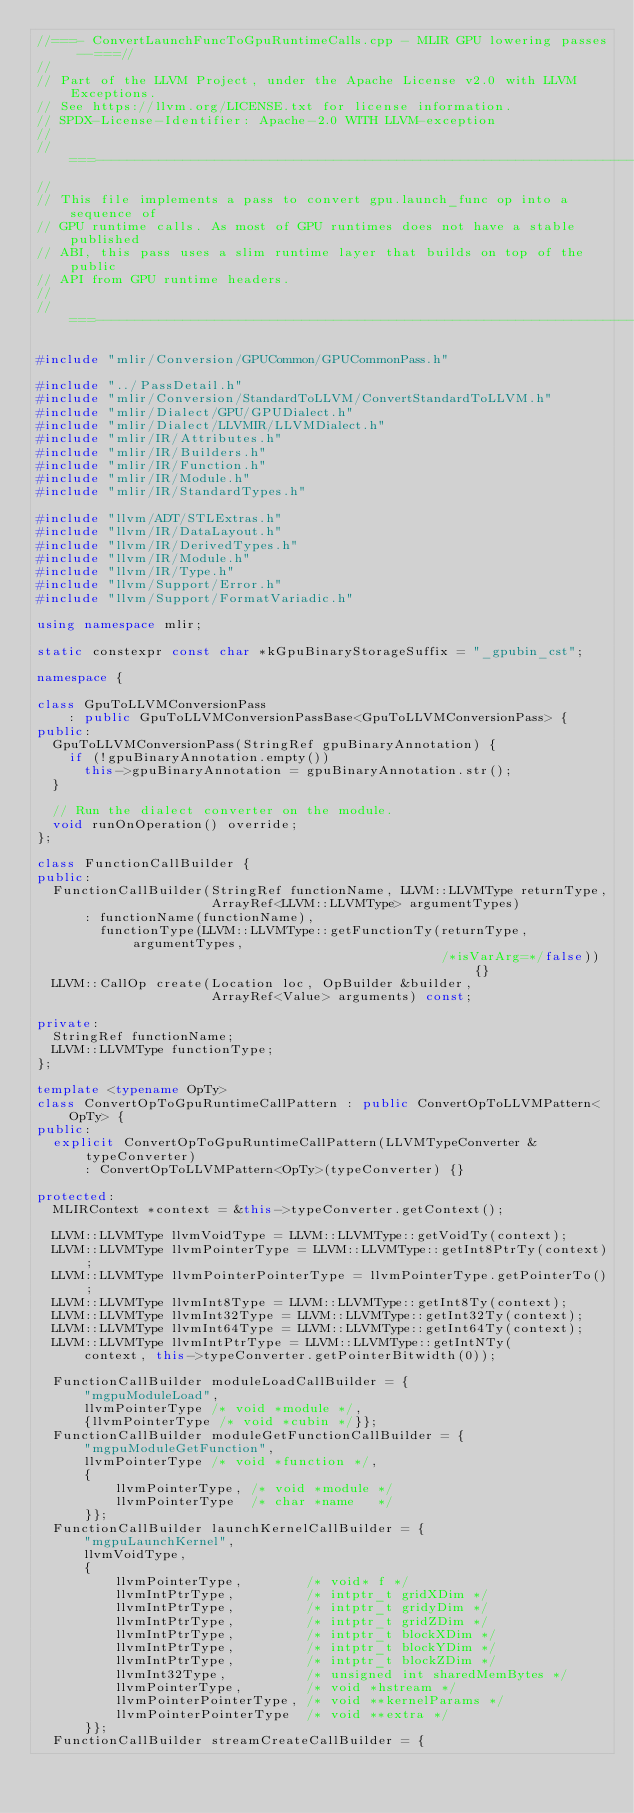<code> <loc_0><loc_0><loc_500><loc_500><_C++_>//===- ConvertLaunchFuncToGpuRuntimeCalls.cpp - MLIR GPU lowering passes --===//
//
// Part of the LLVM Project, under the Apache License v2.0 with LLVM Exceptions.
// See https://llvm.org/LICENSE.txt for license information.
// SPDX-License-Identifier: Apache-2.0 WITH LLVM-exception
//
//===----------------------------------------------------------------------===//
//
// This file implements a pass to convert gpu.launch_func op into a sequence of
// GPU runtime calls. As most of GPU runtimes does not have a stable published
// ABI, this pass uses a slim runtime layer that builds on top of the public
// API from GPU runtime headers.
//
//===----------------------------------------------------------------------===//

#include "mlir/Conversion/GPUCommon/GPUCommonPass.h"

#include "../PassDetail.h"
#include "mlir/Conversion/StandardToLLVM/ConvertStandardToLLVM.h"
#include "mlir/Dialect/GPU/GPUDialect.h"
#include "mlir/Dialect/LLVMIR/LLVMDialect.h"
#include "mlir/IR/Attributes.h"
#include "mlir/IR/Builders.h"
#include "mlir/IR/Function.h"
#include "mlir/IR/Module.h"
#include "mlir/IR/StandardTypes.h"

#include "llvm/ADT/STLExtras.h"
#include "llvm/IR/DataLayout.h"
#include "llvm/IR/DerivedTypes.h"
#include "llvm/IR/Module.h"
#include "llvm/IR/Type.h"
#include "llvm/Support/Error.h"
#include "llvm/Support/FormatVariadic.h"

using namespace mlir;

static constexpr const char *kGpuBinaryStorageSuffix = "_gpubin_cst";

namespace {

class GpuToLLVMConversionPass
    : public GpuToLLVMConversionPassBase<GpuToLLVMConversionPass> {
public:
  GpuToLLVMConversionPass(StringRef gpuBinaryAnnotation) {
    if (!gpuBinaryAnnotation.empty())
      this->gpuBinaryAnnotation = gpuBinaryAnnotation.str();
  }

  // Run the dialect converter on the module.
  void runOnOperation() override;
};

class FunctionCallBuilder {
public:
  FunctionCallBuilder(StringRef functionName, LLVM::LLVMType returnType,
                      ArrayRef<LLVM::LLVMType> argumentTypes)
      : functionName(functionName),
        functionType(LLVM::LLVMType::getFunctionTy(returnType, argumentTypes,
                                                   /*isVarArg=*/false)) {}
  LLVM::CallOp create(Location loc, OpBuilder &builder,
                      ArrayRef<Value> arguments) const;

private:
  StringRef functionName;
  LLVM::LLVMType functionType;
};

template <typename OpTy>
class ConvertOpToGpuRuntimeCallPattern : public ConvertOpToLLVMPattern<OpTy> {
public:
  explicit ConvertOpToGpuRuntimeCallPattern(LLVMTypeConverter &typeConverter)
      : ConvertOpToLLVMPattern<OpTy>(typeConverter) {}

protected:
  MLIRContext *context = &this->typeConverter.getContext();

  LLVM::LLVMType llvmVoidType = LLVM::LLVMType::getVoidTy(context);
  LLVM::LLVMType llvmPointerType = LLVM::LLVMType::getInt8PtrTy(context);
  LLVM::LLVMType llvmPointerPointerType = llvmPointerType.getPointerTo();
  LLVM::LLVMType llvmInt8Type = LLVM::LLVMType::getInt8Ty(context);
  LLVM::LLVMType llvmInt32Type = LLVM::LLVMType::getInt32Ty(context);
  LLVM::LLVMType llvmInt64Type = LLVM::LLVMType::getInt64Ty(context);
  LLVM::LLVMType llvmIntPtrType = LLVM::LLVMType::getIntNTy(
      context, this->typeConverter.getPointerBitwidth(0));

  FunctionCallBuilder moduleLoadCallBuilder = {
      "mgpuModuleLoad",
      llvmPointerType /* void *module */,
      {llvmPointerType /* void *cubin */}};
  FunctionCallBuilder moduleGetFunctionCallBuilder = {
      "mgpuModuleGetFunction",
      llvmPointerType /* void *function */,
      {
          llvmPointerType, /* void *module */
          llvmPointerType  /* char *name   */
      }};
  FunctionCallBuilder launchKernelCallBuilder = {
      "mgpuLaunchKernel",
      llvmVoidType,
      {
          llvmPointerType,        /* void* f */
          llvmIntPtrType,         /* intptr_t gridXDim */
          llvmIntPtrType,         /* intptr_t gridyDim */
          llvmIntPtrType,         /* intptr_t gridZDim */
          llvmIntPtrType,         /* intptr_t blockXDim */
          llvmIntPtrType,         /* intptr_t blockYDim */
          llvmIntPtrType,         /* intptr_t blockZDim */
          llvmInt32Type,          /* unsigned int sharedMemBytes */
          llvmPointerType,        /* void *hstream */
          llvmPointerPointerType, /* void **kernelParams */
          llvmPointerPointerType  /* void **extra */
      }};
  FunctionCallBuilder streamCreateCallBuilder = {</code> 